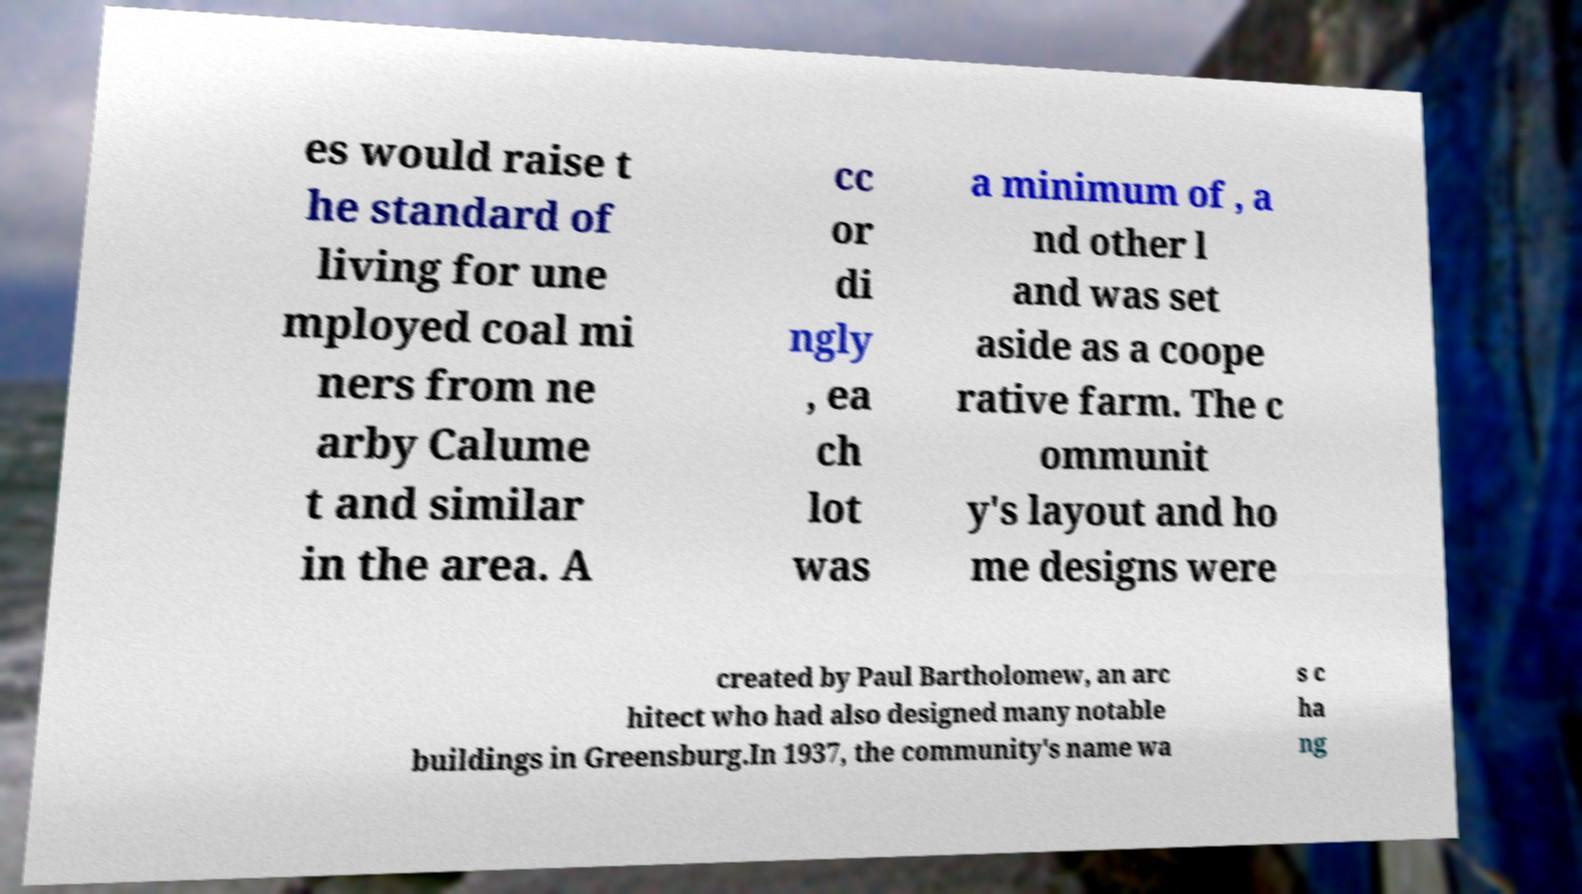Please identify and transcribe the text found in this image. es would raise t he standard of living for une mployed coal mi ners from ne arby Calume t and similar in the area. A cc or di ngly , ea ch lot was a minimum of , a nd other l and was set aside as a coope rative farm. The c ommunit y's layout and ho me designs were created by Paul Bartholomew, an arc hitect who had also designed many notable buildings in Greensburg.In 1937, the community's name wa s c ha ng 